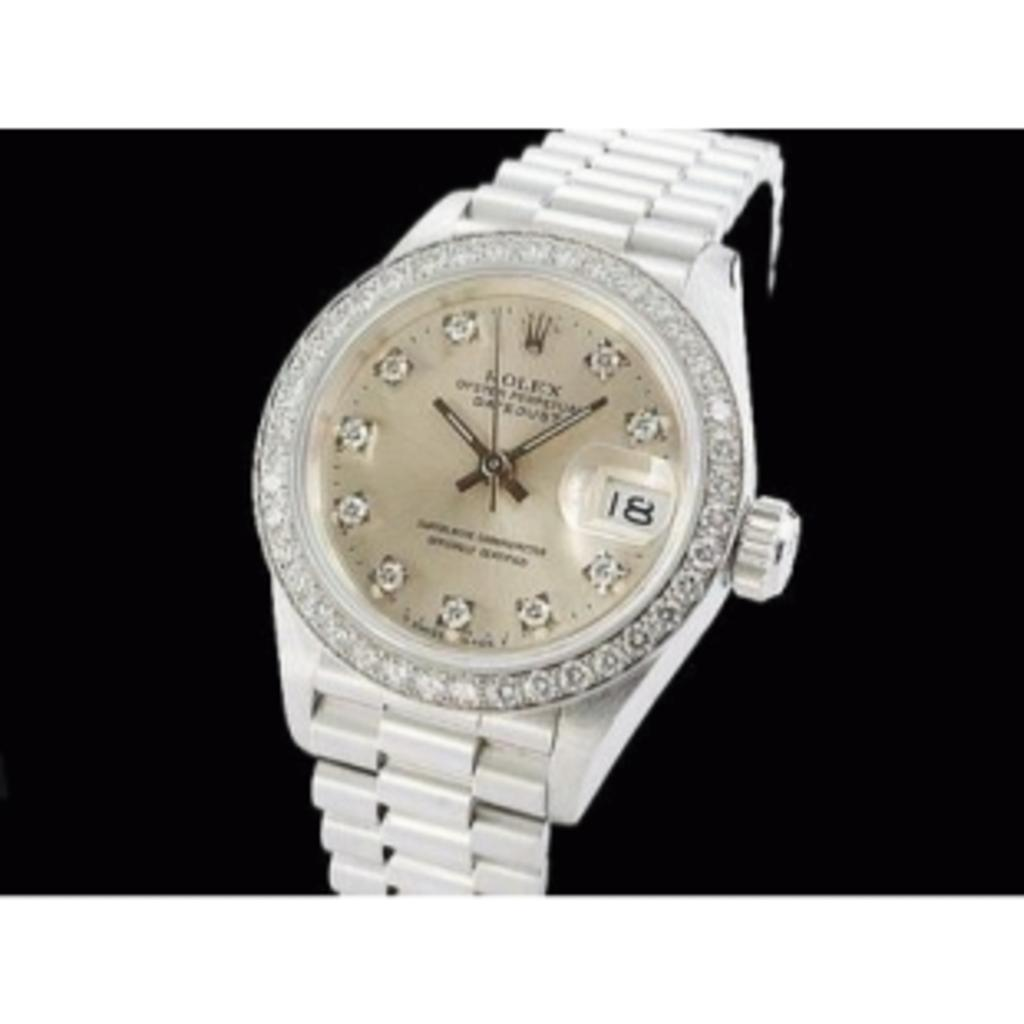<image>
Describe the image concisely. A silver women's Rolex watch covered in jewels and a gold face 